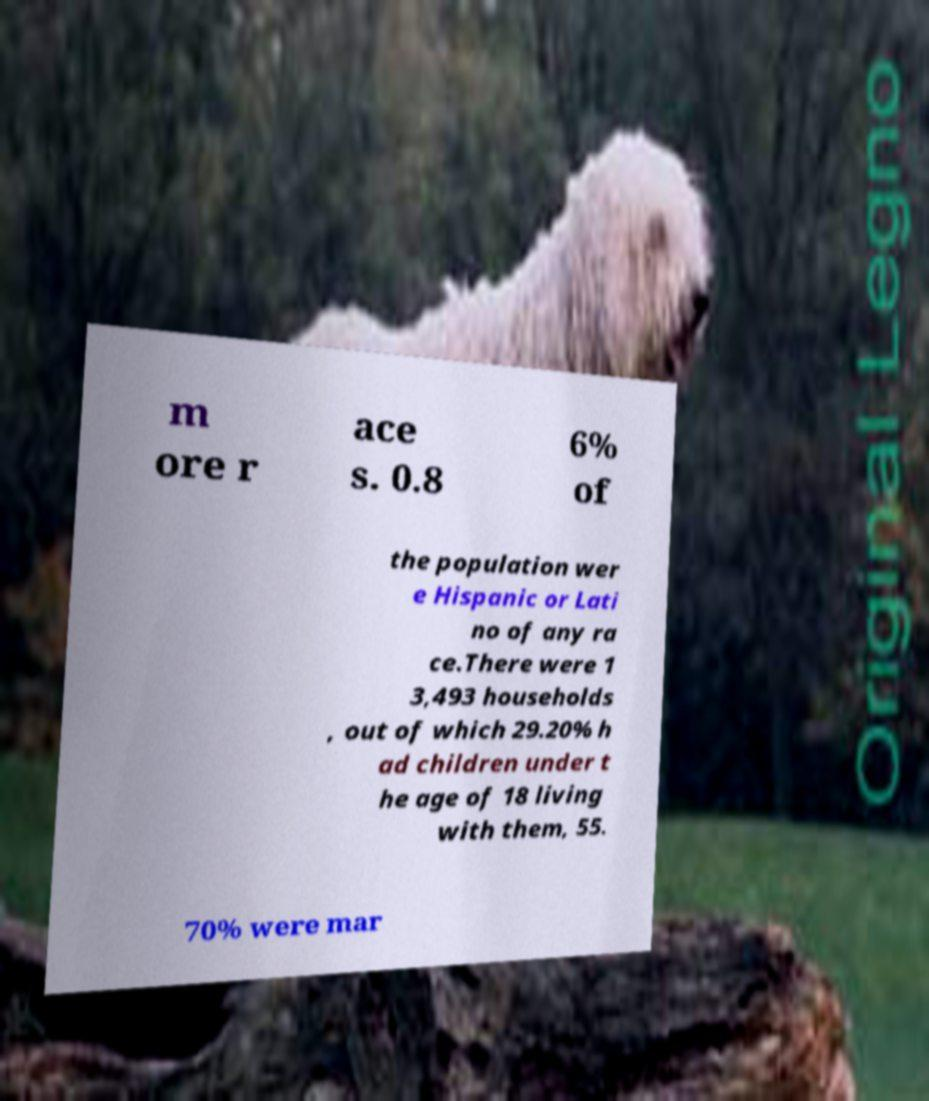Please read and relay the text visible in this image. What does it say? m ore r ace s. 0.8 6% of the population wer e Hispanic or Lati no of any ra ce.There were 1 3,493 households , out of which 29.20% h ad children under t he age of 18 living with them, 55. 70% were mar 